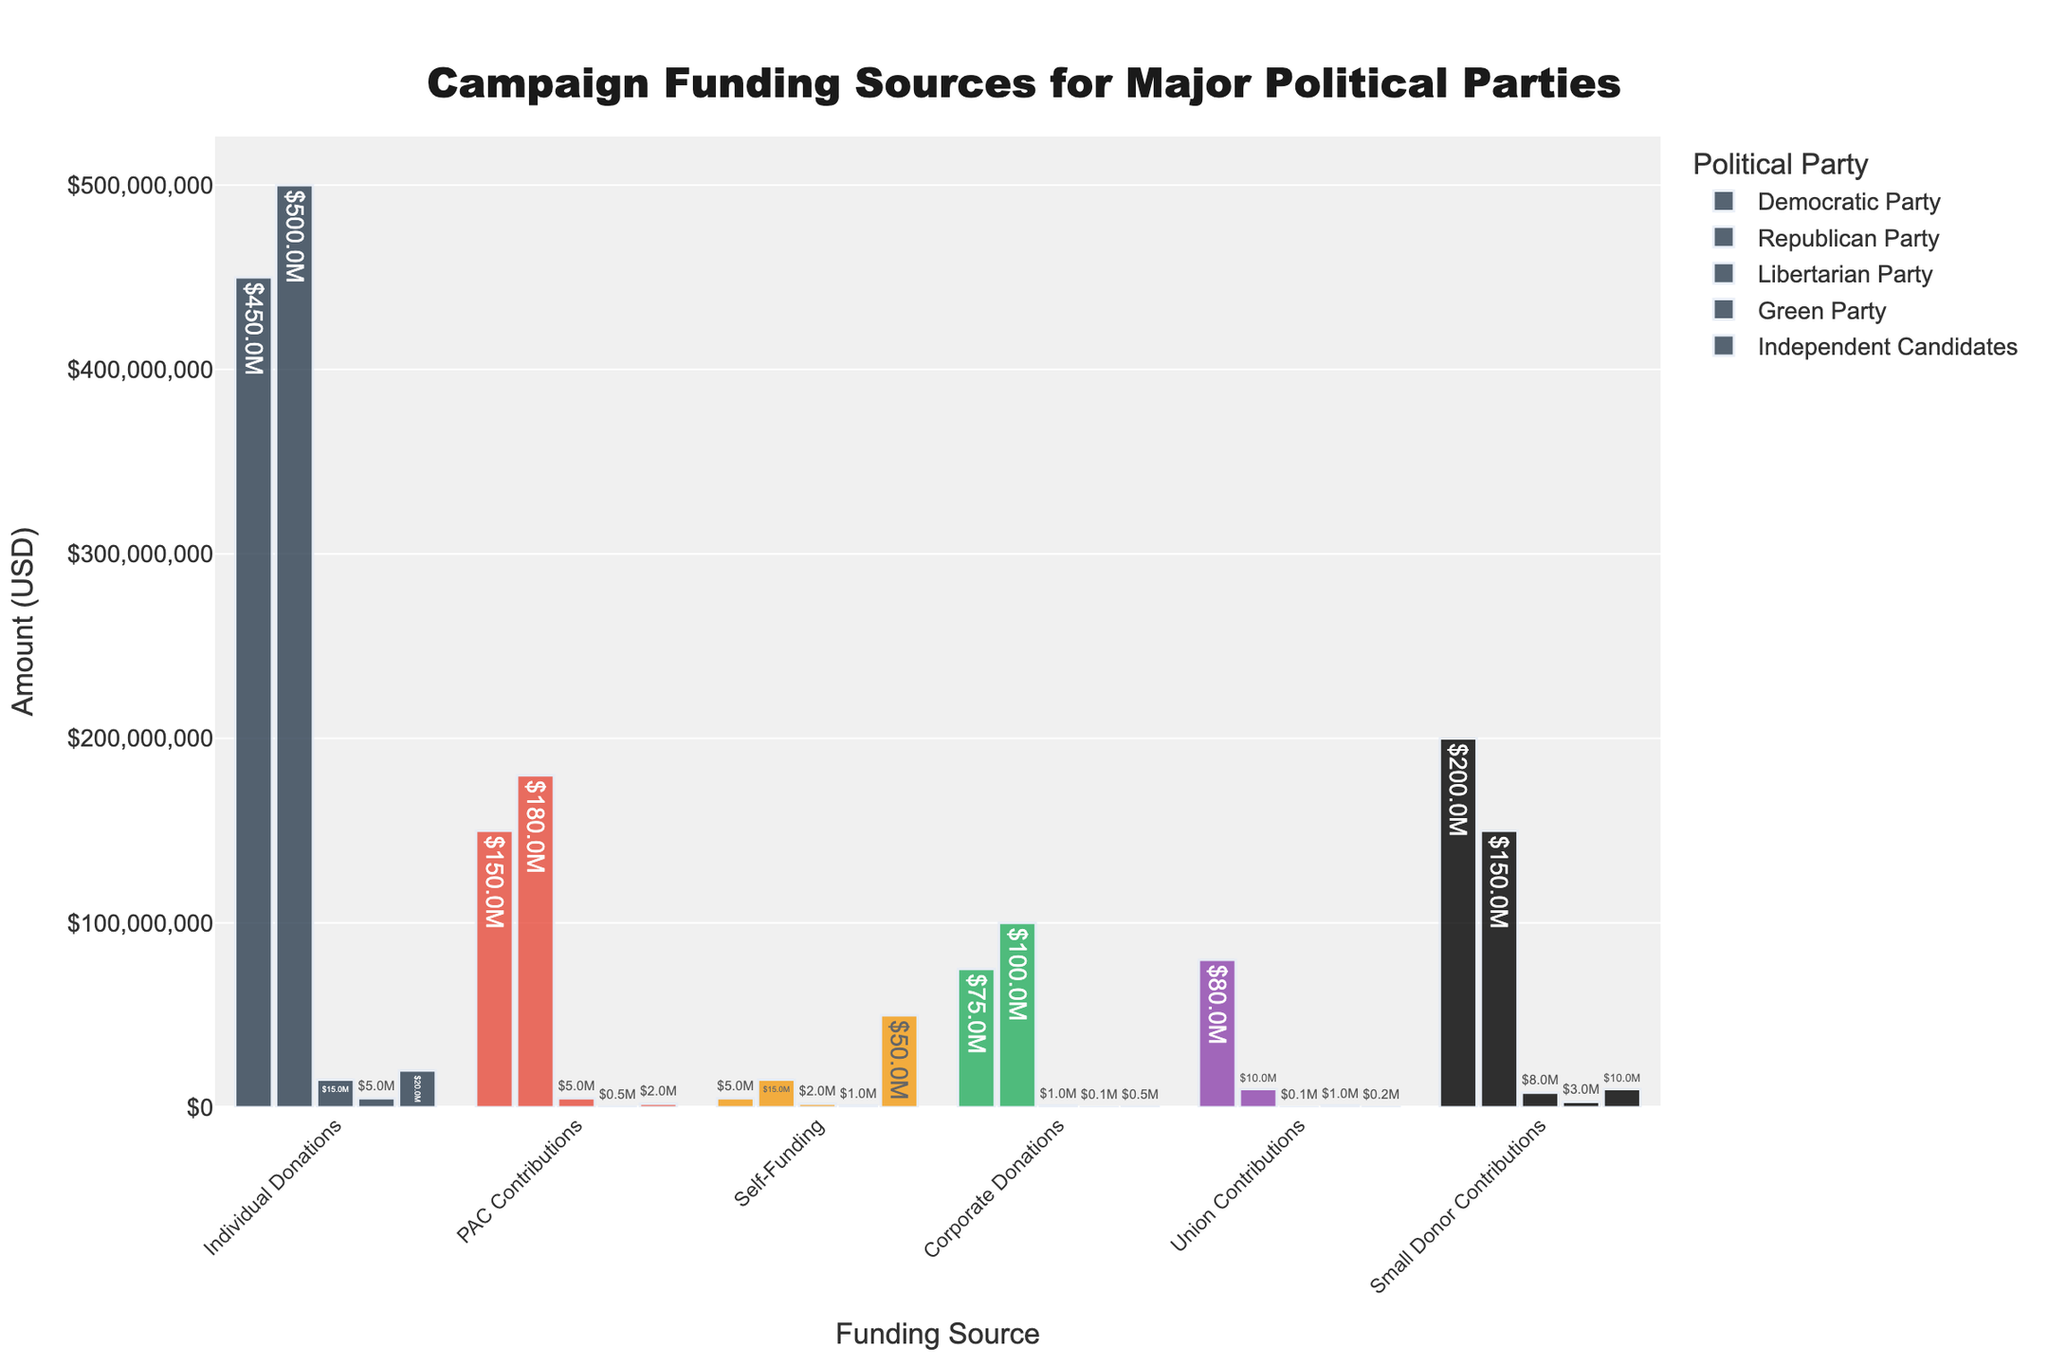What is the total amount raised by the Republican Party? We need to sum up all the funding sources for the Republican Party: Individual Donations ($500M), PAC Contributions ($180M), Self-Funding ($15M), Corporate Donations ($100M), Union Contributions ($10M), and Small Donor Contributions ($150M). Total = $500M + $180M + $15M + $100M + $10M + $150M = $955M
Answer: $955M Which party received the most from Corporate Donations? We compare the Corporate Donations amounts for each party: Democratic Party ($75M), Republican Party ($100M), Libertarian Party ($1M), Green Party ($0.1M), Independent Candidates ($0.5M). The Republican Party received the most with $100M
Answer: Republican Party What is the difference in Individual Donations between the Democratic Party and the Republican Party? We need to find the difference between Individual Donations for the Democratic Party ($450M) and the Republican Party ($500M). Difference = $500M - $450M = $50M
Answer: $50M How do Union Contributions to the Green Party compare with Union Contributions to the Democratic Party? We compare Union Contributions to the Green Party ($1M) with those to the Democratic Party ($80M). The Democratic Party received much more than the Green Party
Answer: Democratic Party received more What is the sum of PAC Contributions and Small Donor Contributions for the Independent Candidates? We need to sum PAC Contributions ($2M) and Small Donor Contributions ($10M) for Independent Candidates. Total = $2M + $10M = $12M
Answer: $12M Which party received the least from Small Donor Contributions? We compare the Small Donor Contributions for each party: Democratic Party ($200M), Republican Party ($150M), Libertarian Party ($8M), Green Party ($3M), Independent Candidates ($10M). The Green Party received the least with $3M
Answer: Green Party What is the relative height of the Small Donor Contributions bar for the Democratic Party compared to the Self-Funding bar for the same party? We compare the height of the bars: Small Donor Contributions for the Democratic Party is $200M, and Self-Funding is $5M. The Small Donor Contributions bar is significantly higher by $195M
Answer: Small Donor Contributions bar is significantly higher What is the combined total amount of Union Contributions for all parties? We sum the Union Contributions for all parties: Democratic Party ($80M), Republican Party ($10M), Libertarian Party ($0.1M), Green Party ($1M), Independent Candidates ($0.2M). Total = $80M + $10M + $0.1M + $1M + $0.2M = $91.3M
Answer: $91.3M Which funding source contributed the most to the Libertarian Party? We compare all funding sources for the Libertarian Party: Individual Donations ($15M), PAC Contributions ($5M), Self-Funding ($2M), Corporate Donations ($1M), Union Contributions ($0.1M), Small Donor Contributions ($8M). Individual Donations, with $15M, contributed the most
Answer: Individual Donations How much more did the Republican Party raise from Self-Funding compared to the Libertarian Party? We find the difference between Self-Funding for the Republican Party ($15M) and the Libertarian Party ($2M). Difference = $15M - $2M = $13M
Answer: $13M 